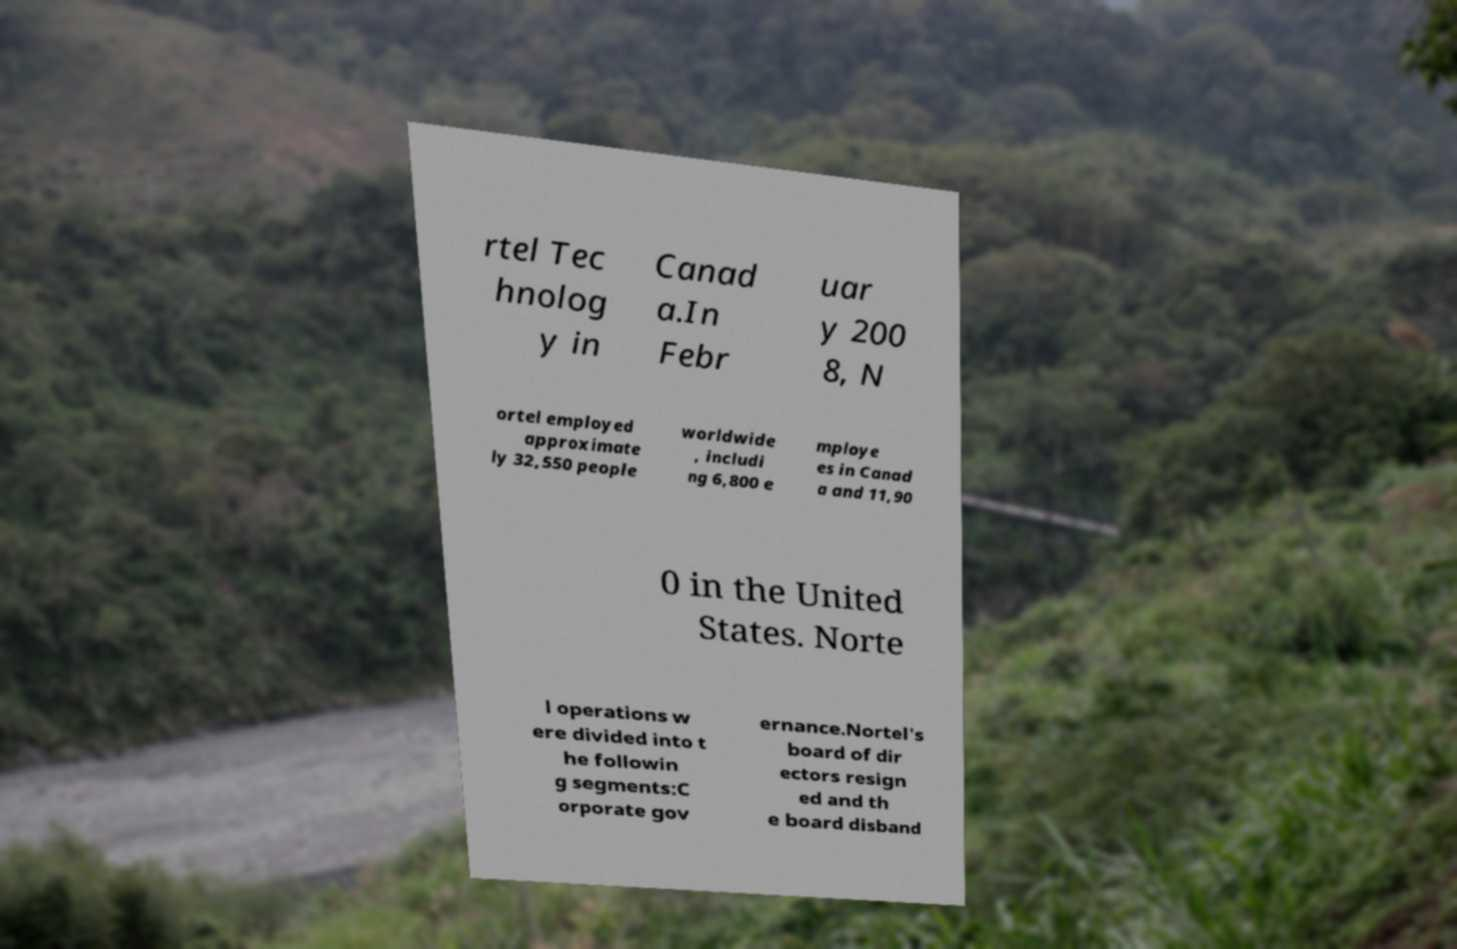Can you read and provide the text displayed in the image?This photo seems to have some interesting text. Can you extract and type it out for me? rtel Tec hnolog y in Canad a.In Febr uar y 200 8, N ortel employed approximate ly 32,550 people worldwide , includi ng 6,800 e mploye es in Canad a and 11,90 0 in the United States. Norte l operations w ere divided into t he followin g segments:C orporate gov ernance.Nortel's board of dir ectors resign ed and th e board disband 